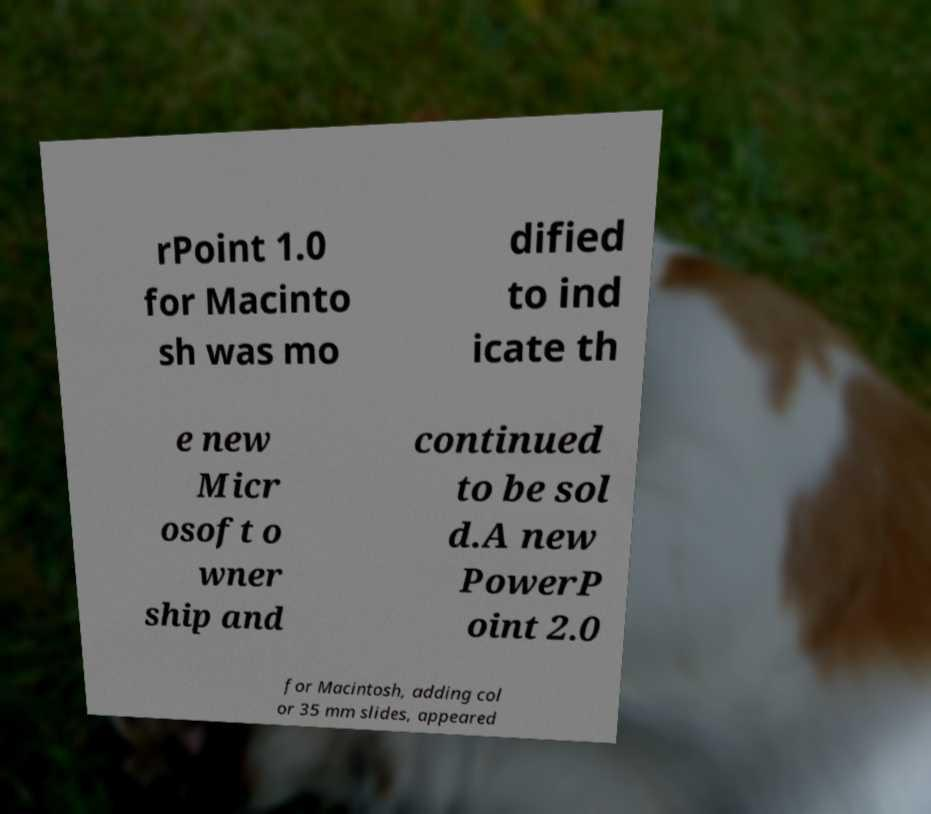There's text embedded in this image that I need extracted. Can you transcribe it verbatim? rPoint 1.0 for Macinto sh was mo dified to ind icate th e new Micr osoft o wner ship and continued to be sol d.A new PowerP oint 2.0 for Macintosh, adding col or 35 mm slides, appeared 